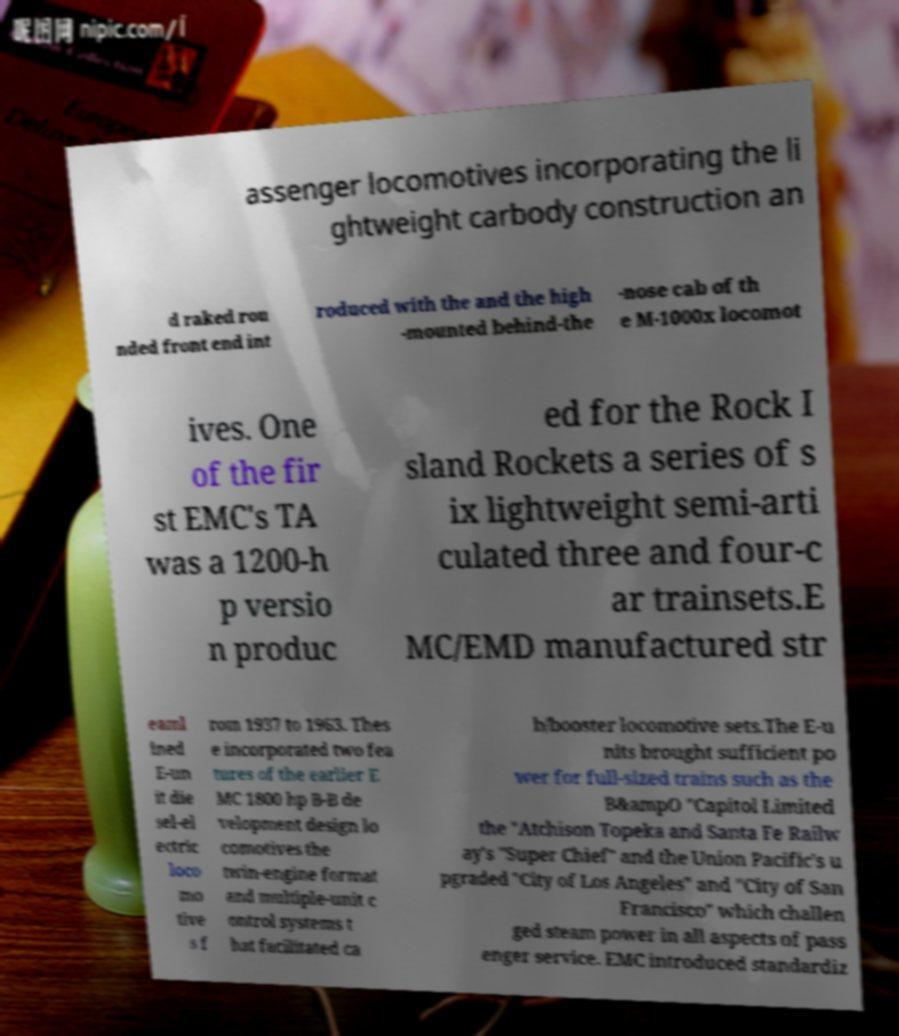Please read and relay the text visible in this image. What does it say? assenger locomotives incorporating the li ghtweight carbody construction an d raked rou nded front end int roduced with the and the high -mounted behind-the -nose cab of th e M-1000x locomot ives. One of the fir st EMC's TA was a 1200-h p versio n produc ed for the Rock I sland Rockets a series of s ix lightweight semi-arti culated three and four-c ar trainsets.E MC/EMD manufactured str eaml ined E-un it die sel-el ectric loco mo tive s f rom 1937 to 1963. Thes e incorporated two fea tures of the earlier E MC 1800 hp B-B de velopment design lo comotives the twin-engine format and multiple-unit c ontrol systems t hat facilitated ca b/booster locomotive sets.The E-u nits brought sufficient po wer for full-sized trains such as the B&ampO "Capitol Limited the "Atchison Topeka and Santa Fe Railw ay's "Super Chief" and the Union Pacific's u pgraded "City of Los Angeles" and "City of San Francisco" which challen ged steam power in all aspects of pass enger service. EMC introduced standardiz 